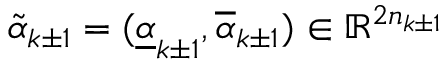<formula> <loc_0><loc_0><loc_500><loc_500>\widetilde { \alpha } _ { k \pm 1 } = ( \underline { \alpha } _ { k \pm 1 } , \overline { \alpha } _ { k \pm 1 } ) \in \mathbb { R } ^ { 2 n _ { k \pm 1 } }</formula> 